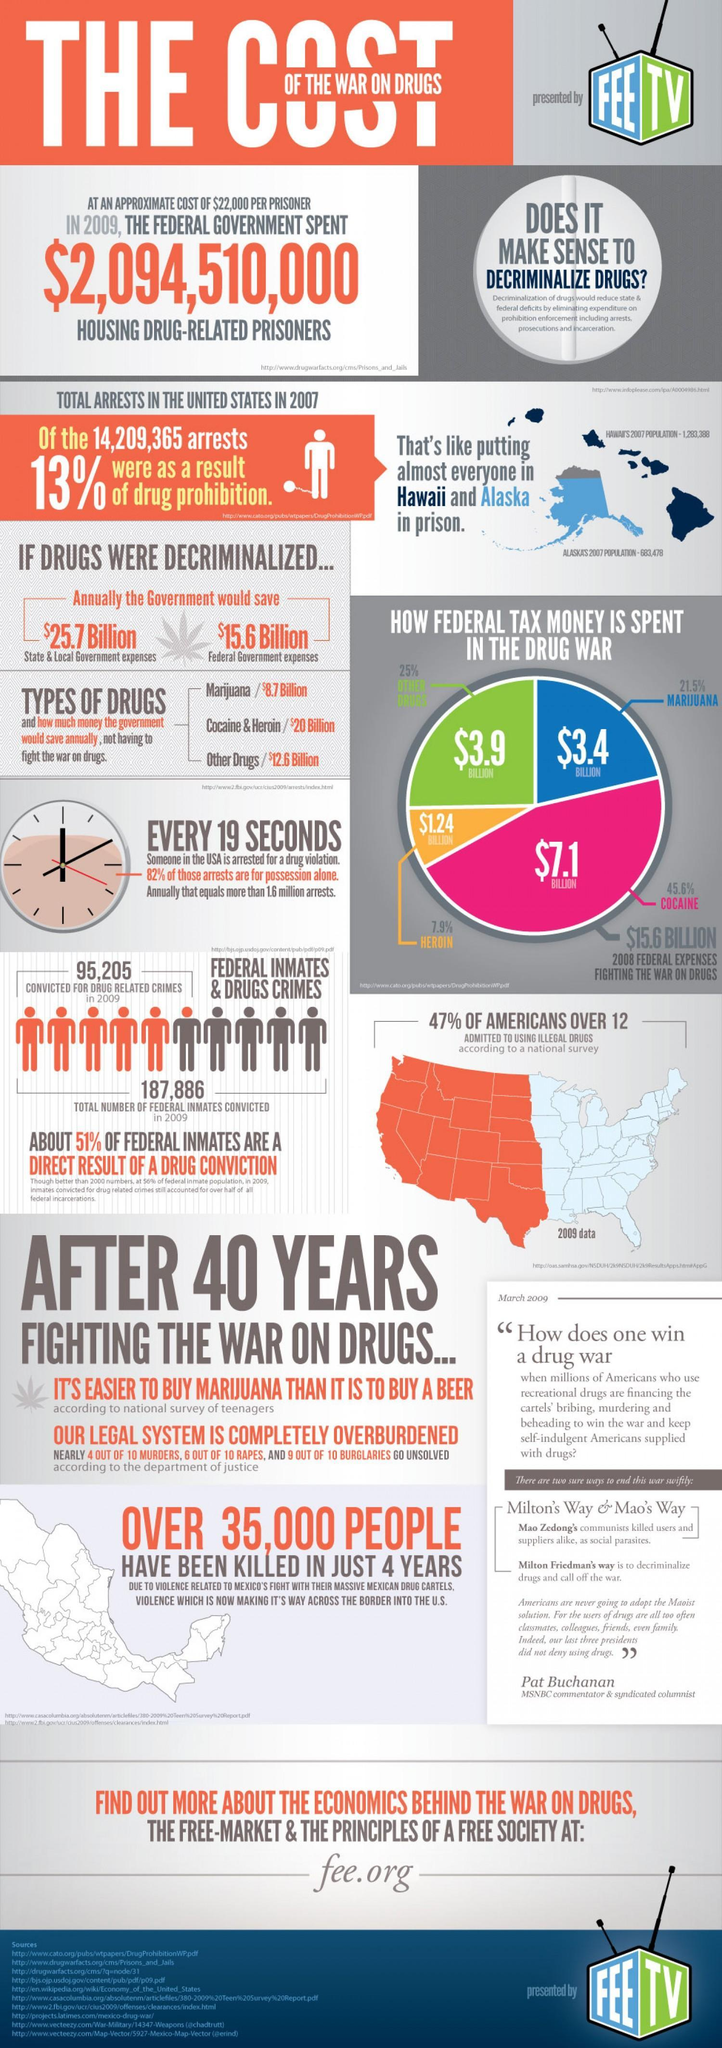how much federal government expenses could be saved if drugs were decrimilalized
Answer the question with a short phrase. $15.6 Billion where is the federal tax money spent least in drug war heroin what percentage of teenagers and above admitted to using illegal drugs 47% In the pie chart what is the colour for other drugs shown, green or pink green how many were convicted for drug related crimes in 2009 95,205 the count of people arrested in 2007 is equal to the population of which states Hawaii and Alaska 